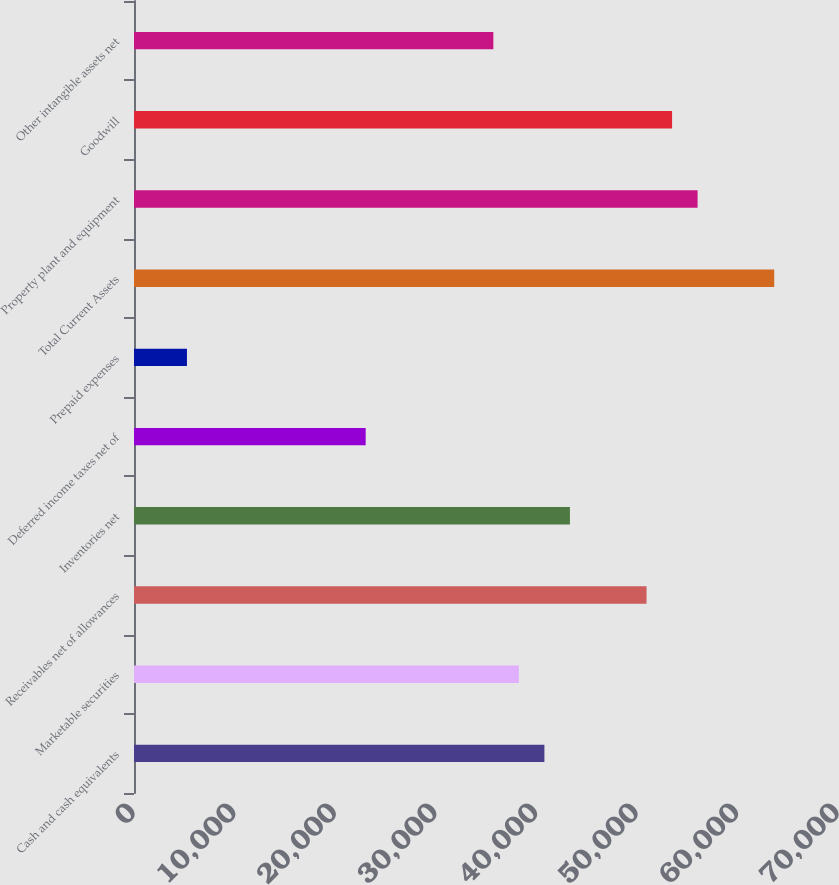Convert chart. <chart><loc_0><loc_0><loc_500><loc_500><bar_chart><fcel>Cash and cash equivalents<fcel>Marketable securities<fcel>Receivables net of allowances<fcel>Inventories net<fcel>Deferred income taxes net of<fcel>Prepaid expenses<fcel>Total Current Assets<fcel>Property plant and equipment<fcel>Goodwill<fcel>Other intangible assets net<nl><fcel>40807.8<fcel>38269<fcel>50963<fcel>43346.6<fcel>23036.2<fcel>5264.6<fcel>63657<fcel>56040.6<fcel>53501.8<fcel>35730.2<nl></chart> 